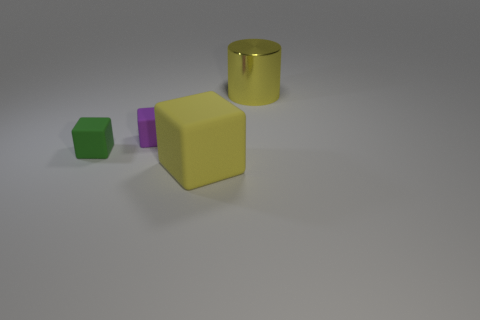What number of cylinders are red shiny objects or purple matte things?
Your answer should be compact. 0. There is another big cube that is made of the same material as the purple block; what color is it?
Provide a succinct answer. Yellow. Are there fewer large metal cylinders than spheres?
Offer a terse response. No. There is a large object that is in front of the metallic cylinder; is its shape the same as the yellow object that is behind the large yellow matte block?
Provide a succinct answer. No. What number of things are either purple things or large yellow cylinders?
Your answer should be compact. 2. What color is the other thing that is the same size as the green rubber thing?
Your answer should be compact. Purple. What number of purple things are in front of the big yellow thing that is left of the yellow metallic cylinder?
Provide a succinct answer. 0. What number of things are right of the green matte cube and left of the large rubber block?
Your answer should be very brief. 1. What number of things are objects left of the big yellow metal object or tiny matte blocks that are on the left side of the small purple matte block?
Offer a very short reply. 3. How many other objects are the same size as the yellow shiny thing?
Your response must be concise. 1. 